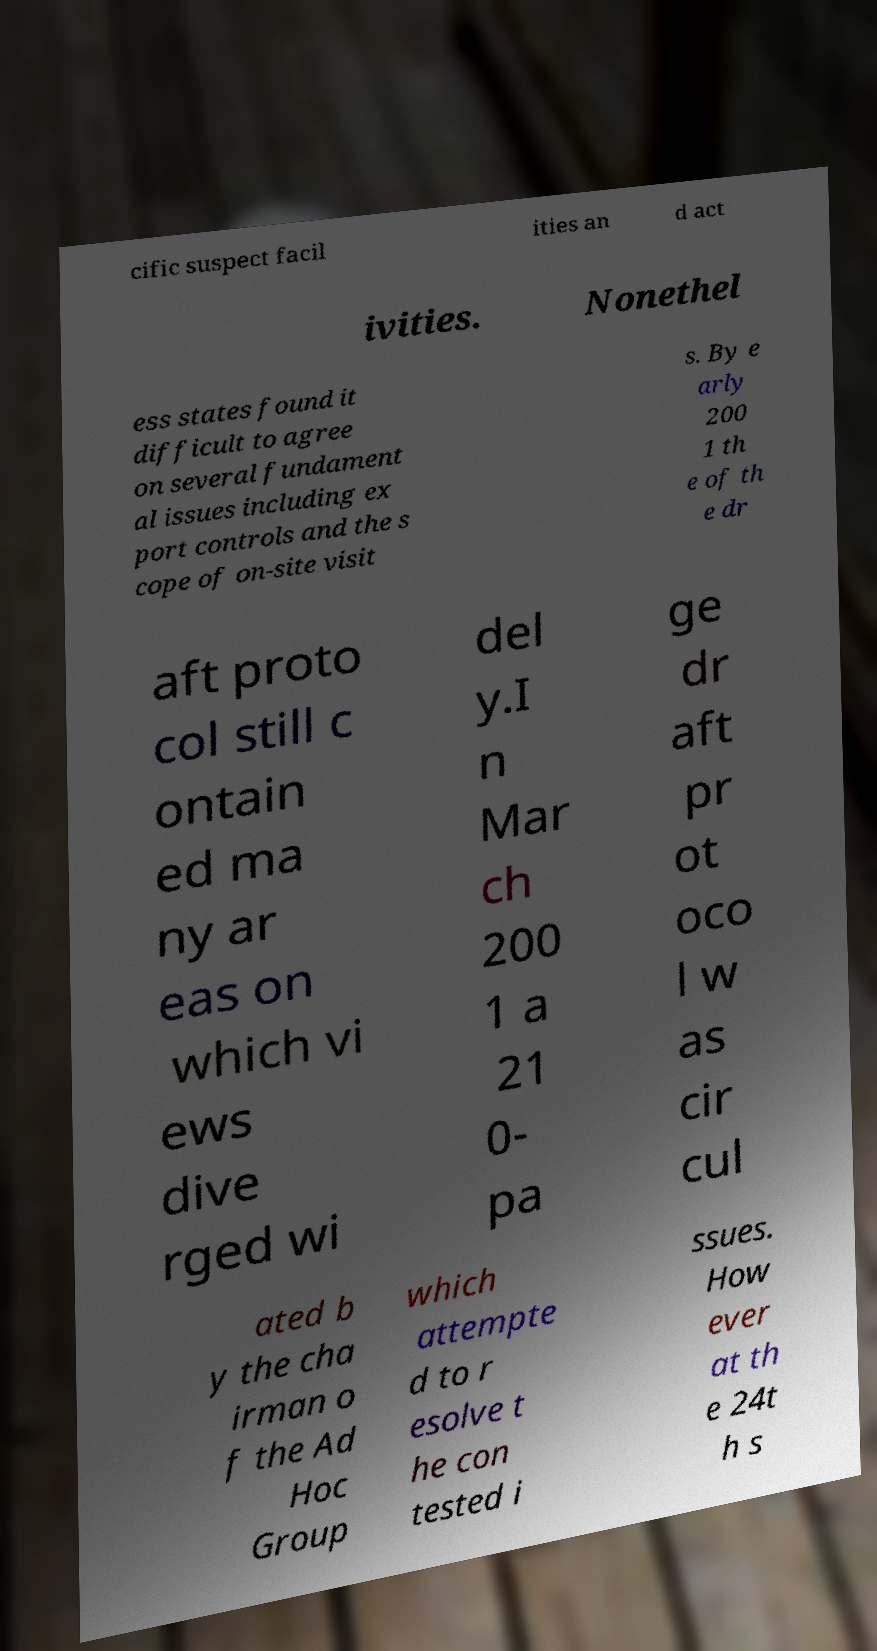Can you accurately transcribe the text from the provided image for me? cific suspect facil ities an d act ivities. Nonethel ess states found it difficult to agree on several fundament al issues including ex port controls and the s cope of on-site visit s. By e arly 200 1 th e of th e dr aft proto col still c ontain ed ma ny ar eas on which vi ews dive rged wi del y.I n Mar ch 200 1 a 21 0- pa ge dr aft pr ot oco l w as cir cul ated b y the cha irman o f the Ad Hoc Group which attempte d to r esolve t he con tested i ssues. How ever at th e 24t h s 